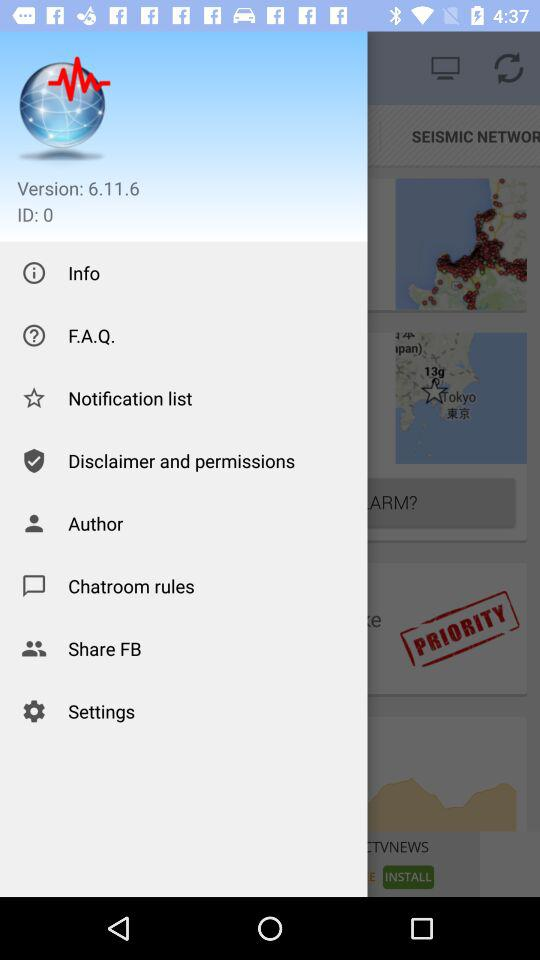How many notifications are there in the list?
When the provided information is insufficient, respond with <no answer>. <no answer> 